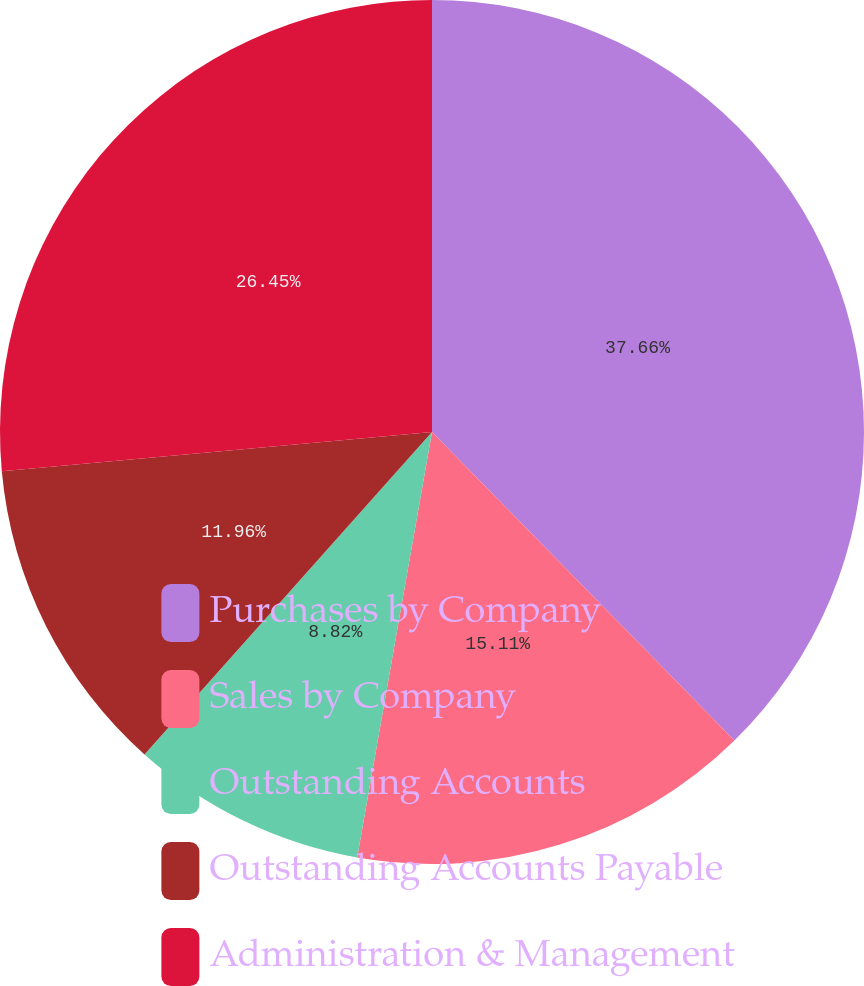Convert chart. <chart><loc_0><loc_0><loc_500><loc_500><pie_chart><fcel>Purchases by Company<fcel>Sales by Company<fcel>Outstanding Accounts<fcel>Outstanding Accounts Payable<fcel>Administration & Management<nl><fcel>37.66%<fcel>15.11%<fcel>8.82%<fcel>11.96%<fcel>26.45%<nl></chart> 